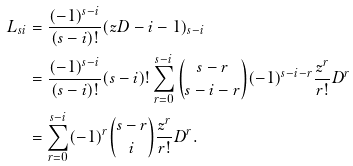Convert formula to latex. <formula><loc_0><loc_0><loc_500><loc_500>L _ { s i } & = \frac { ( - 1 ) ^ { s - i } } { ( s - i ) ! } ( z D - i - 1 ) _ { s - i } \\ & = \frac { ( - 1 ) ^ { s - i } } { ( s - i ) ! } ( s - i ) ! \sum _ { r = 0 } ^ { s - i } { s - r \choose s - i - r } ( - 1 ) ^ { s - i - r } \frac { z ^ { r } } { r ! } D ^ { r } \\ & = \sum _ { r = 0 } ^ { s - i } ( - 1 ) ^ { r } { s - r \choose i } \frac { z ^ { r } } { r ! } D ^ { r } .</formula> 